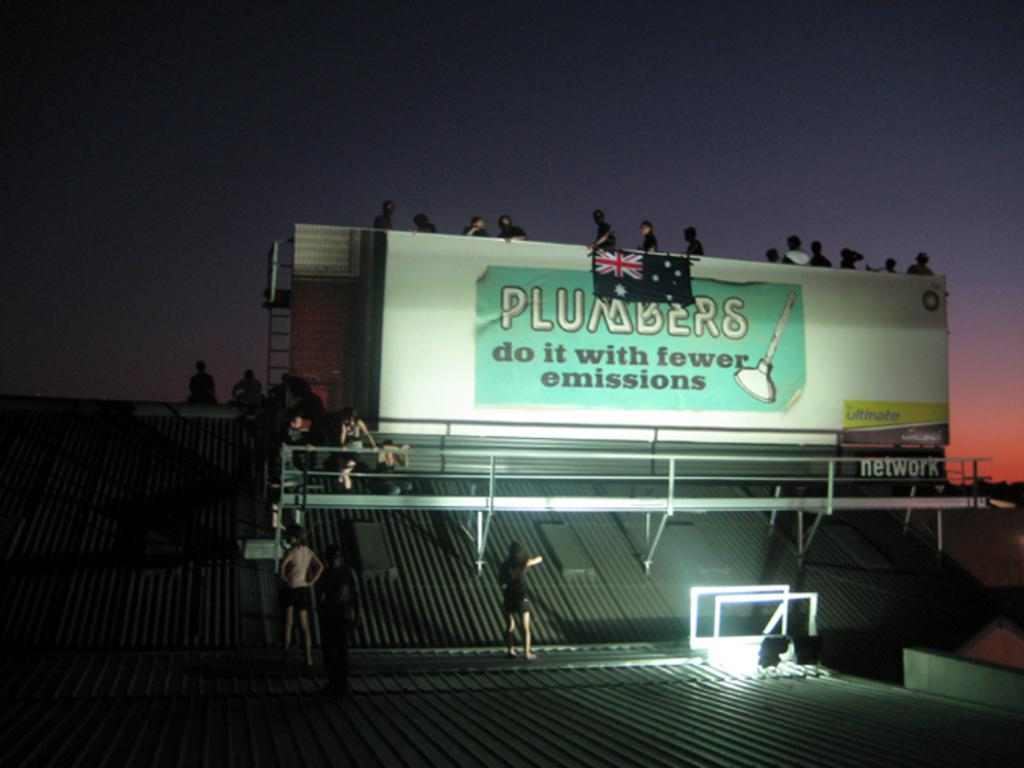<image>
Describe the image concisely. A billboard says Plumbers do it with fewer emissions on it. 